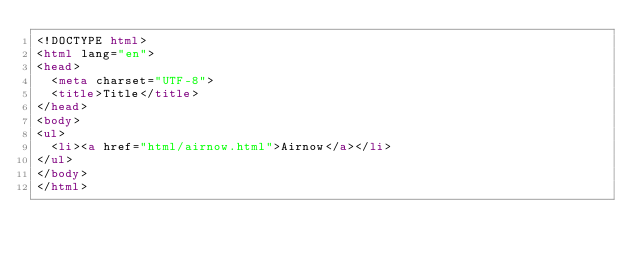Convert code to text. <code><loc_0><loc_0><loc_500><loc_500><_HTML_><!DOCTYPE html>
<html lang="en">
<head>
  <meta charset="UTF-8">
  <title>Title</title>
</head>
<body>
<ul>
  <li><a href="html/airnow.html">Airnow</a></li>
</ul>
</body>
</html>

</code> 